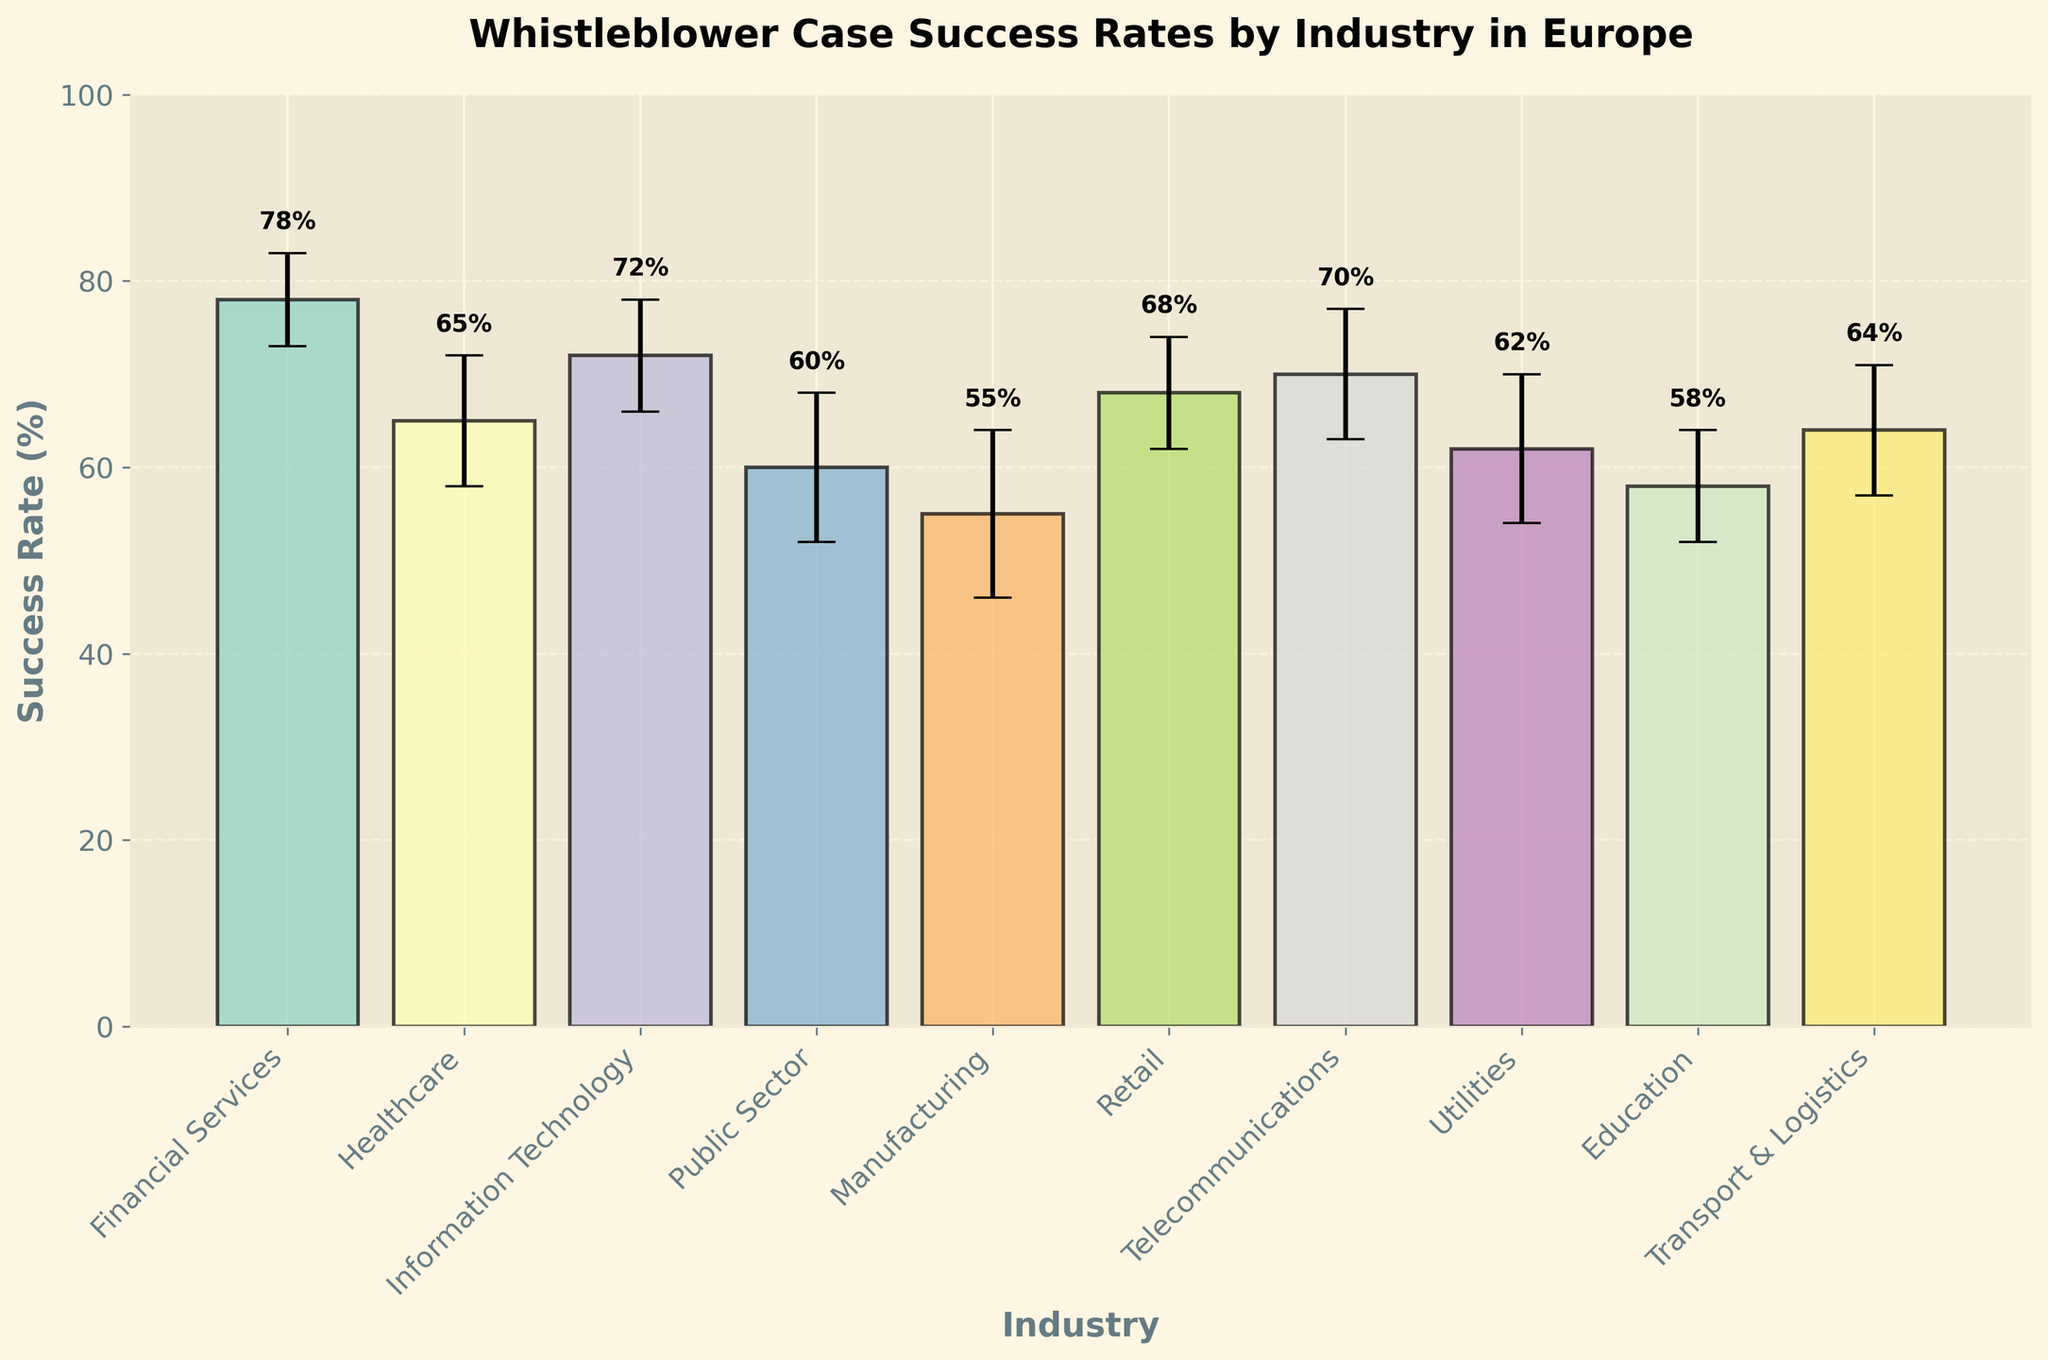How many industries are represented in the figure? The x-axis lists the industries. Counting the number of unique labels will give the answer.
Answer: 10 Which industry has the highest success rate? Look at the height of the bars on the y-axis to find the bar with the highest value.
Answer: Financial Services What is the success rate for the Retail industry? Find the bar labeled "Retail" on the x-axis and read its height on the y-axis.
Answer: 68% What is the difference in success rates between the Manufacturing and Healthcare industries? Find the y-axis values for both Manufacturing (55%) and Healthcare (65%) and calculate the difference.
Answer: 10% Which industry has the lowest error margin? Look at the error bars and identify which one is shortest.
Answer: Education Compare the success rates between Telecommunications and Utilities. Which is higher and by how much? Read the y-axis values for both industries: Telecommunications (70%) and Utilities (62%). Subtract the smaller value from the larger value.
Answer: Telecommunications by 8% What is the range of success rates for the industries shown in the figure? Find the maximum and minimum y-axis values among the industries: Financial Services (78%) and Manufacturing (55%). Subtract the minimum from the maximum value.
Answer: 23% What is the average error margin across all industries? Sum up all the error margins and divide by the number of industries (7+8+9+6+7+6+5+8+7+8 = 71, 71/10).
Answer: 7.1% If you categorize success rates into 'high' (above 70%) and 'low' (70% and below), which industries fall into the 'high' category? Identify bars with y-axis values above 70%: Financial Services (78%) and Telecommunications (70%, equal but included as 'high').
Answer: Financial Services, Telecommunications What is the median success rate among all industries? List all success rates in ascending order (55%, 58%, 60%, 62%, 64%, 65%, 68%, 70%, 72%, 78%) and find the middle value. For 10 values, the median is the average of the 5th and 6th values (64% and 65%).
Answer: 64.5% 